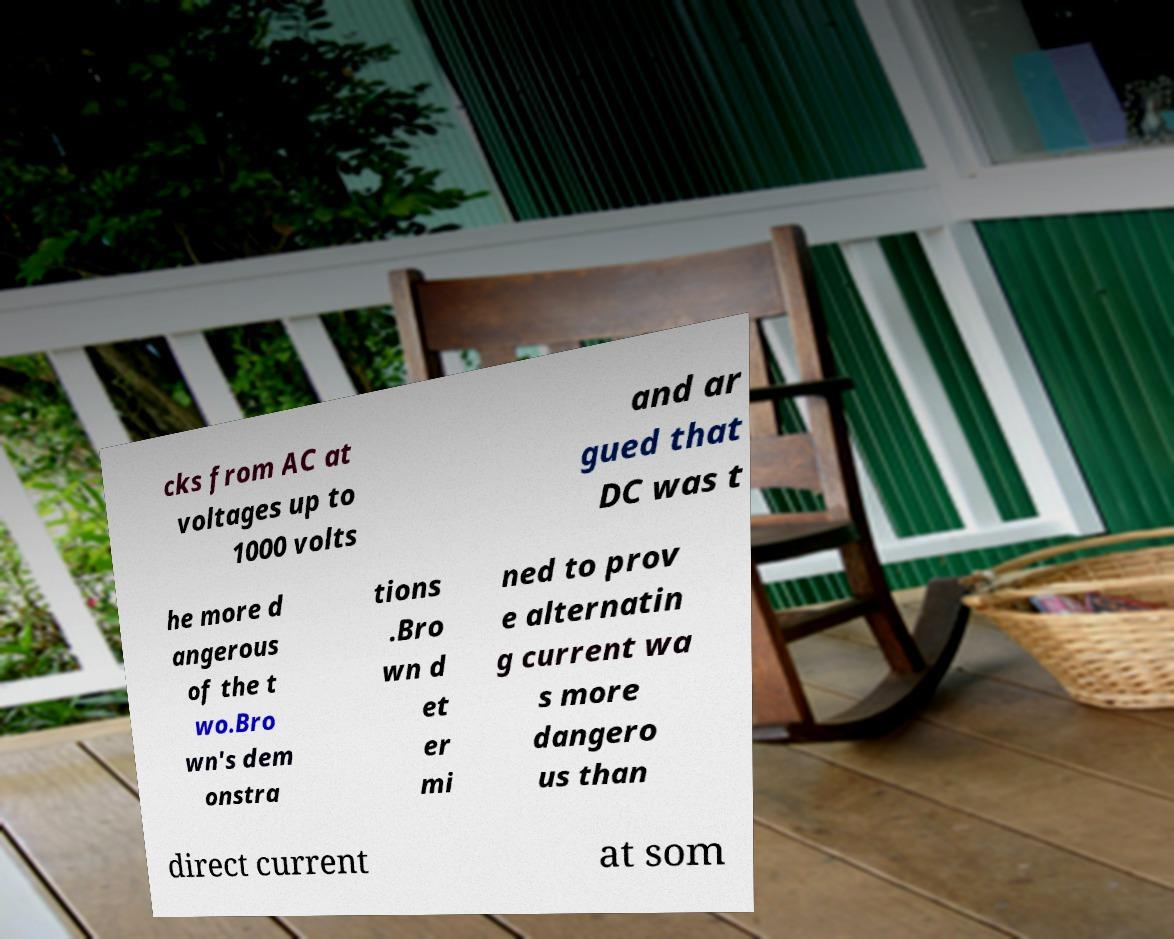Can you accurately transcribe the text from the provided image for me? cks from AC at voltages up to 1000 volts and ar gued that DC was t he more d angerous of the t wo.Bro wn's dem onstra tions .Bro wn d et er mi ned to prov e alternatin g current wa s more dangero us than direct current at som 